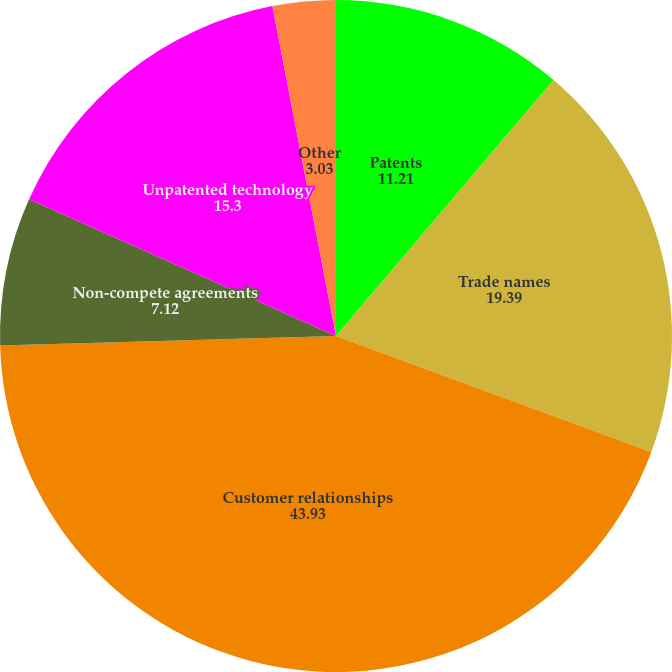Convert chart. <chart><loc_0><loc_0><loc_500><loc_500><pie_chart><fcel>Patents<fcel>Trade names<fcel>Customer relationships<fcel>Non-compete agreements<fcel>Unpatented technology<fcel>Other<nl><fcel>11.21%<fcel>19.39%<fcel>43.93%<fcel>7.12%<fcel>15.3%<fcel>3.03%<nl></chart> 